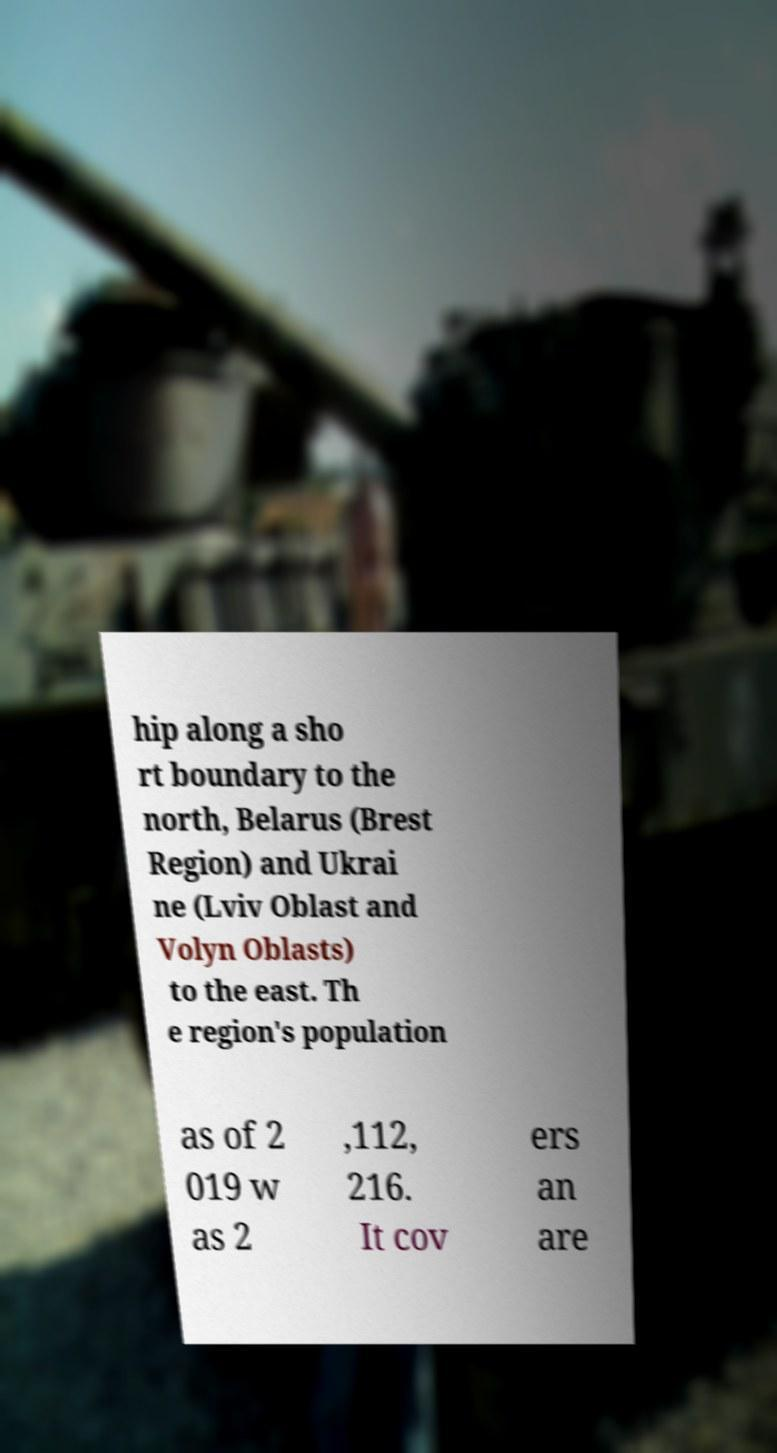I need the written content from this picture converted into text. Can you do that? hip along a sho rt boundary to the north, Belarus (Brest Region) and Ukrai ne (Lviv Oblast and Volyn Oblasts) to the east. Th e region's population as of 2 019 w as 2 ,112, 216. It cov ers an are 